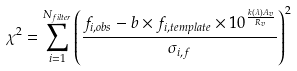Convert formula to latex. <formula><loc_0><loc_0><loc_500><loc_500>\chi ^ { 2 } = \sum _ { i = 1 } ^ { N _ { f i l t e r } } \left ( \frac { f _ { i , o b s } - b \times f _ { i , t e m p l a t e } \times 1 0 ^ { \frac { k ( \lambda ) A _ { v } } { R _ { v } } } } { \sigma _ { i , f } } \right ) ^ { 2 }</formula> 